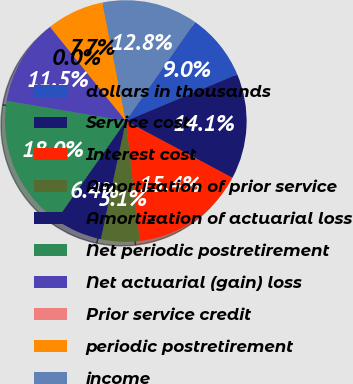Convert chart. <chart><loc_0><loc_0><loc_500><loc_500><pie_chart><fcel>dollars in thousands<fcel>Service cost<fcel>Interest cost<fcel>Amortization of prior service<fcel>Amortization of actuarial loss<fcel>Net periodic postretirement<fcel>Net actuarial (gain) loss<fcel>Prior service credit<fcel>periodic postretirement<fcel>income<nl><fcel>8.97%<fcel>14.1%<fcel>15.38%<fcel>5.13%<fcel>6.41%<fcel>17.95%<fcel>11.54%<fcel>0.0%<fcel>7.69%<fcel>12.82%<nl></chart> 